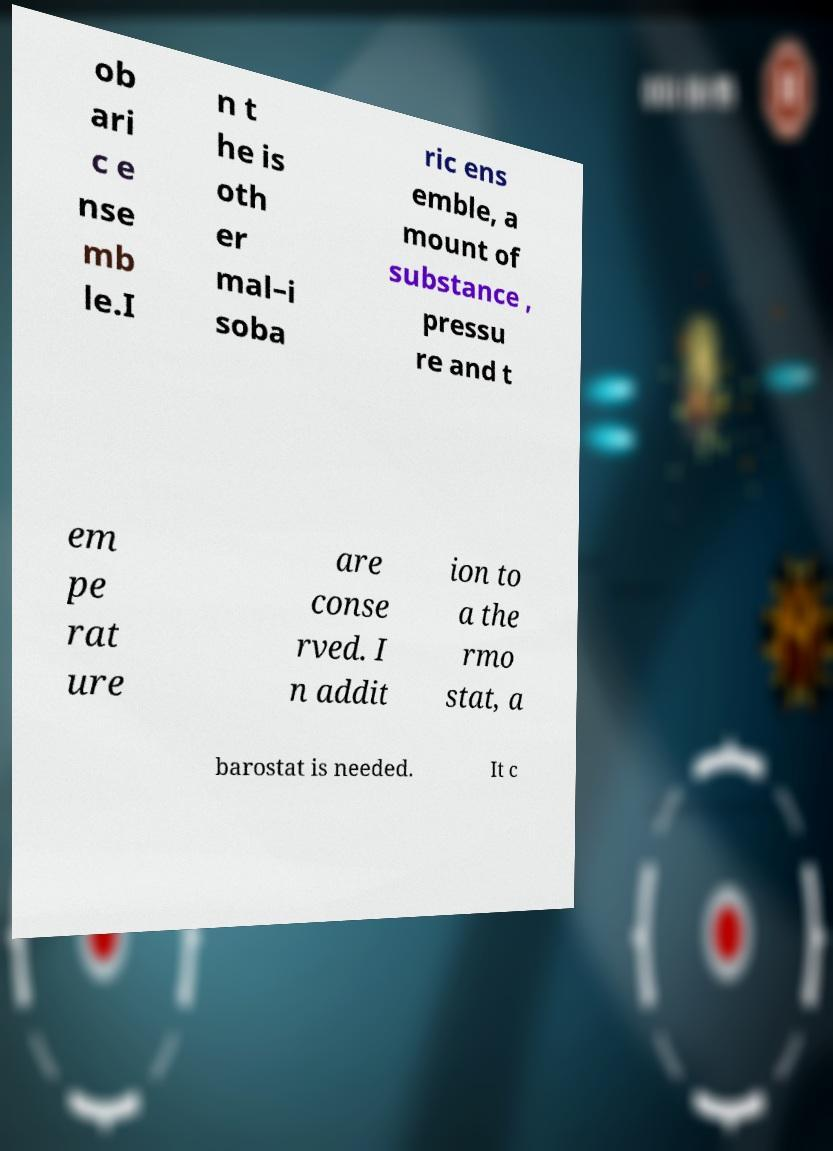Please identify and transcribe the text found in this image. ob ari c e nse mb le.I n t he is oth er mal–i soba ric ens emble, a mount of substance , pressu re and t em pe rat ure are conse rved. I n addit ion to a the rmo stat, a barostat is needed. It c 